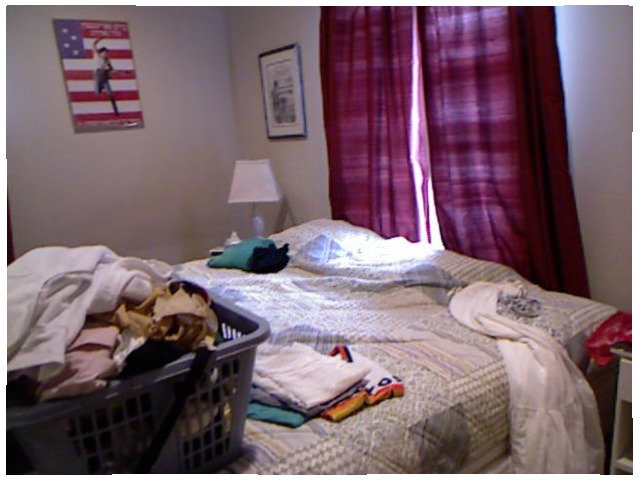<image>
Is the basket on the bed? Yes. Looking at the image, I can see the basket is positioned on top of the bed, with the bed providing support. 